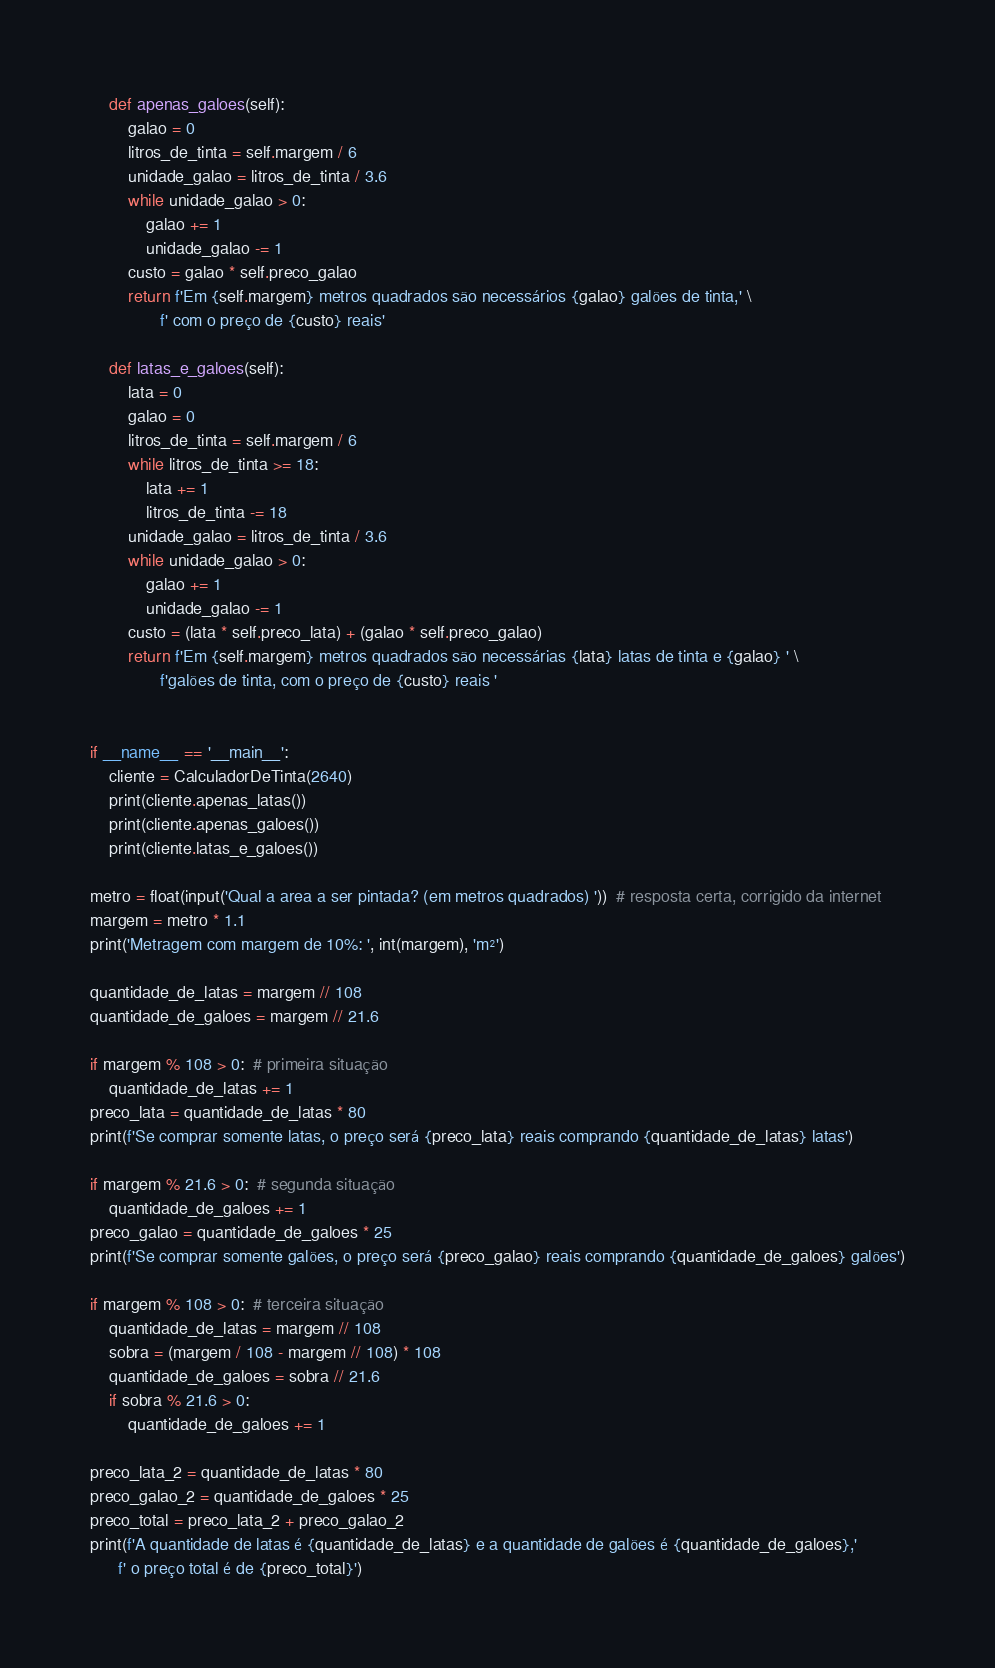Convert code to text. <code><loc_0><loc_0><loc_500><loc_500><_Python_>
    def apenas_galoes(self):
        galao = 0
        litros_de_tinta = self.margem / 6
        unidade_galao = litros_de_tinta / 3.6
        while unidade_galao > 0:
            galao += 1
            unidade_galao -= 1
        custo = galao * self.preco_galao
        return f'Em {self.margem} metros quadrados são necessários {galao} galões de tinta,' \
               f' com o preço de {custo} reais'

    def latas_e_galoes(self):
        lata = 0
        galao = 0
        litros_de_tinta = self.margem / 6
        while litros_de_tinta >= 18:
            lata += 1
            litros_de_tinta -= 18
        unidade_galao = litros_de_tinta / 3.6
        while unidade_galao > 0:
            galao += 1
            unidade_galao -= 1
        custo = (lata * self.preco_lata) + (galao * self.preco_galao)
        return f'Em {self.margem} metros quadrados são necessárias {lata} latas de tinta e {galao} ' \
               f'galões de tinta, com o preço de {custo} reais '


if __name__ == '__main__':
    cliente = CalculadorDeTinta(2640)
    print(cliente.apenas_latas())
    print(cliente.apenas_galoes())
    print(cliente.latas_e_galoes())

metro = float(input('Qual a area a ser pintada? (em metros quadrados) '))  # resposta certa, corrigido da internet
margem = metro * 1.1
print('Metragem com margem de 10%: ', int(margem), 'm²')

quantidade_de_latas = margem // 108
quantidade_de_galoes = margem // 21.6

if margem % 108 > 0:  # primeira situação
    quantidade_de_latas += 1
preco_lata = quantidade_de_latas * 80
print(f'Se comprar somente latas, o preço será {preco_lata} reais comprando {quantidade_de_latas} latas')

if margem % 21.6 > 0:  # segunda situação
    quantidade_de_galoes += 1
preco_galao = quantidade_de_galoes * 25
print(f'Se comprar somente galões, o preço será {preco_galao} reais comprando {quantidade_de_galoes} galões')

if margem % 108 > 0:  # terceira situação
    quantidade_de_latas = margem // 108
    sobra = (margem / 108 - margem // 108) * 108
    quantidade_de_galoes = sobra // 21.6
    if sobra % 21.6 > 0:
        quantidade_de_galoes += 1

preco_lata_2 = quantidade_de_latas * 80
preco_galao_2 = quantidade_de_galoes * 25
preco_total = preco_lata_2 + preco_galao_2
print(f'A quantidade de latas é {quantidade_de_latas} e a quantidade de galões é {quantidade_de_galoes},'
      f' o preço total é de {preco_total}')
</code> 